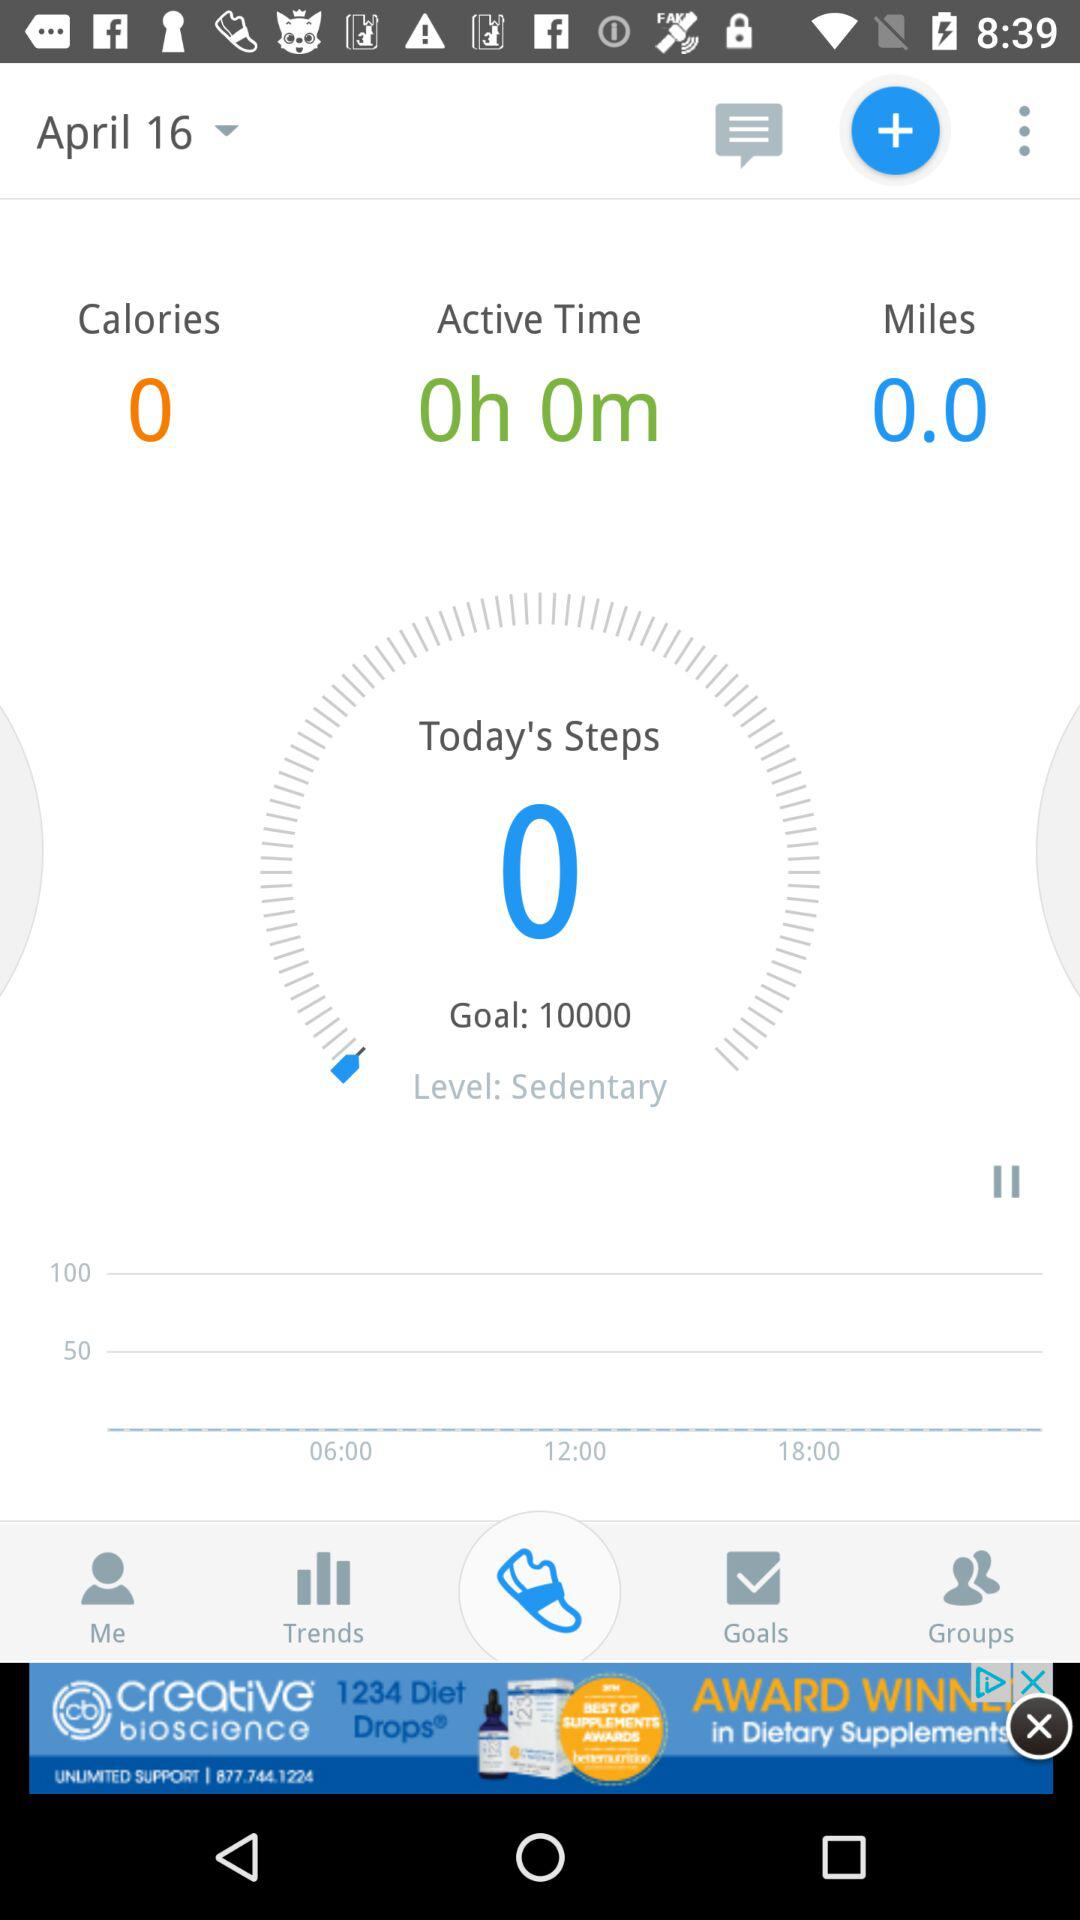Which date is selected? The selected date is April 16. 